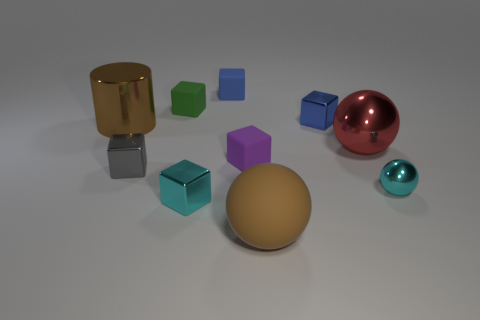There is a matte object that is the same color as the shiny cylinder; what is its size?
Keep it short and to the point. Large. Are there any big red things made of the same material as the tiny purple cube?
Provide a succinct answer. No. What is the thing that is in front of the tiny cyan metal block made of?
Your answer should be compact. Rubber. Do the large object behind the red metallic thing and the small object that is on the right side of the red metal thing have the same color?
Ensure brevity in your answer.  No. What is the color of the rubber ball that is the same size as the red thing?
Provide a short and direct response. Brown. What number of other things are there of the same shape as the tiny blue metallic thing?
Your answer should be very brief. 5. There is a brown object that is in front of the tiny gray metallic block; what is its size?
Your answer should be very brief. Large. What number of small purple cubes are behind the brown thing behind the large brown ball?
Your answer should be compact. 0. What number of other objects are there of the same size as the brown matte ball?
Give a very brief answer. 2. Is the matte ball the same color as the big cylinder?
Provide a succinct answer. Yes. 